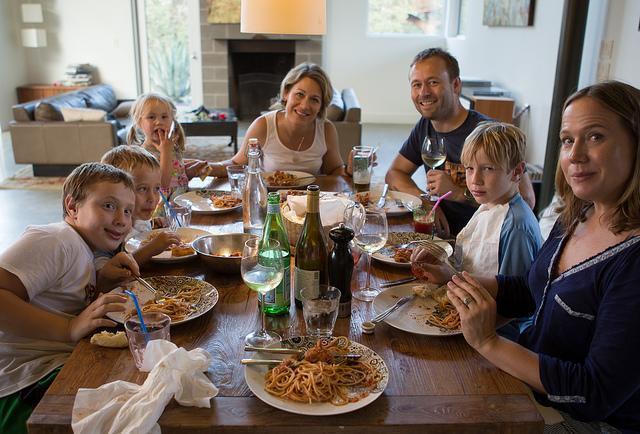How many bottles can be seen?
Give a very brief answer. 2. How many people are in the picture?
Give a very brief answer. 7. How many elephants are there?
Give a very brief answer. 0. 